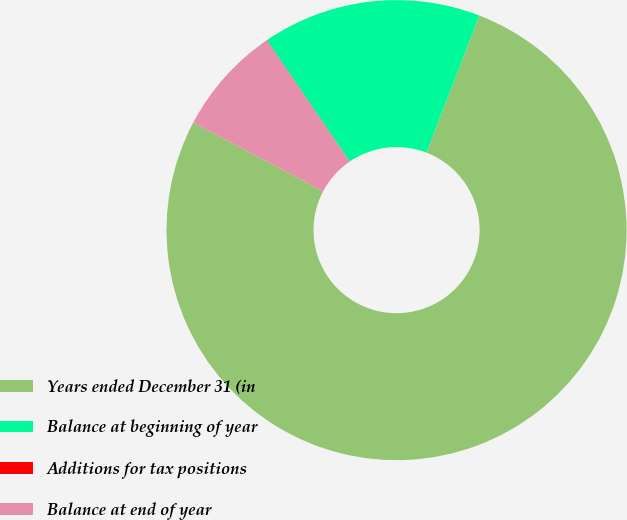Convert chart to OTSL. <chart><loc_0><loc_0><loc_500><loc_500><pie_chart><fcel>Years ended December 31 (in<fcel>Balance at beginning of year<fcel>Additions for tax positions<fcel>Balance at end of year<nl><fcel>76.89%<fcel>15.39%<fcel>0.02%<fcel>7.7%<nl></chart> 